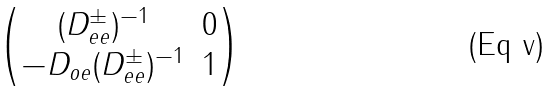Convert formula to latex. <formula><loc_0><loc_0><loc_500><loc_500>\begin{pmatrix} ( D _ { e e } ^ { \pm } ) ^ { - 1 } & 0 \\ - D _ { o e } ( D _ { e e } ^ { \pm } ) ^ { - 1 } & 1 \\ \end{pmatrix}</formula> 